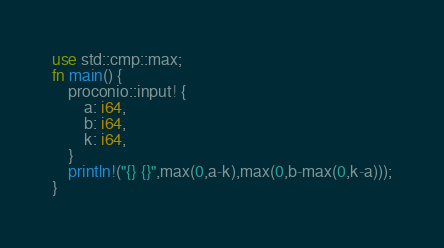<code> <loc_0><loc_0><loc_500><loc_500><_Rust_>use std::cmp::max;
fn main() {
    proconio::input! {
        a: i64,
        b: i64,
        k: i64,
    }
    println!("{} {}",max(0,a-k),max(0,b-max(0,k-a)));
}</code> 